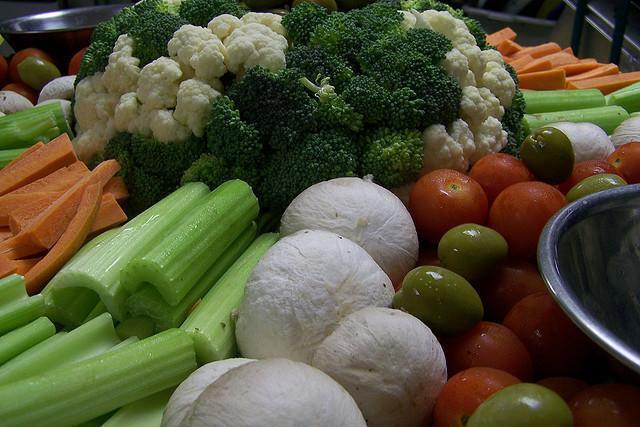How many different vegetables are here?
Give a very brief answer. 7. 